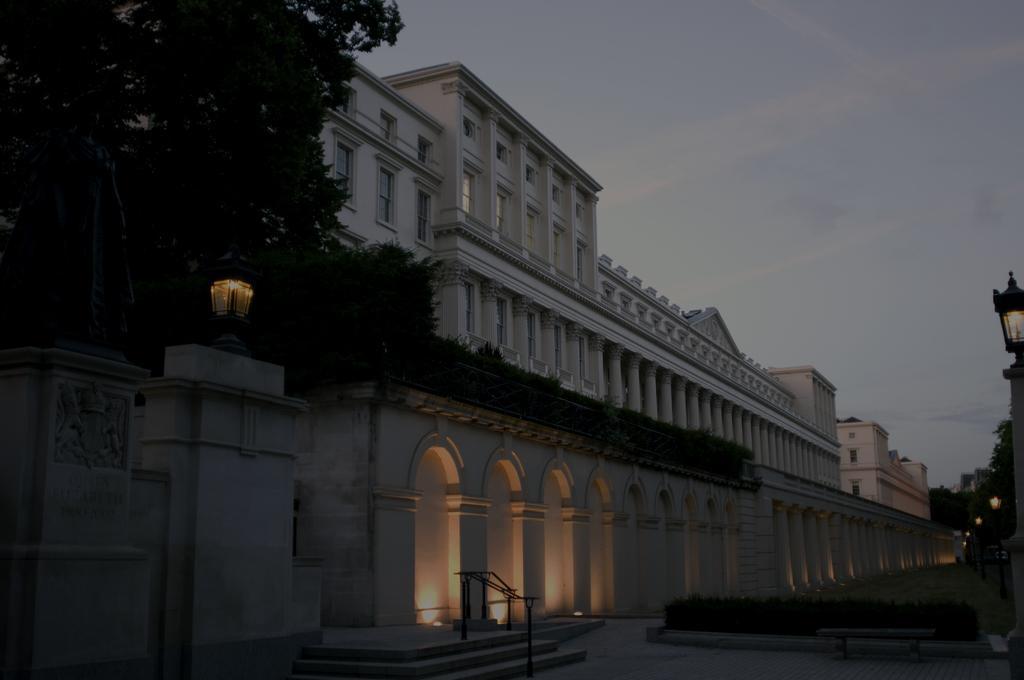In one or two sentences, can you explain what this image depicts? In this image we can see a building, trees, gate lights, light poles and sky in the background. 